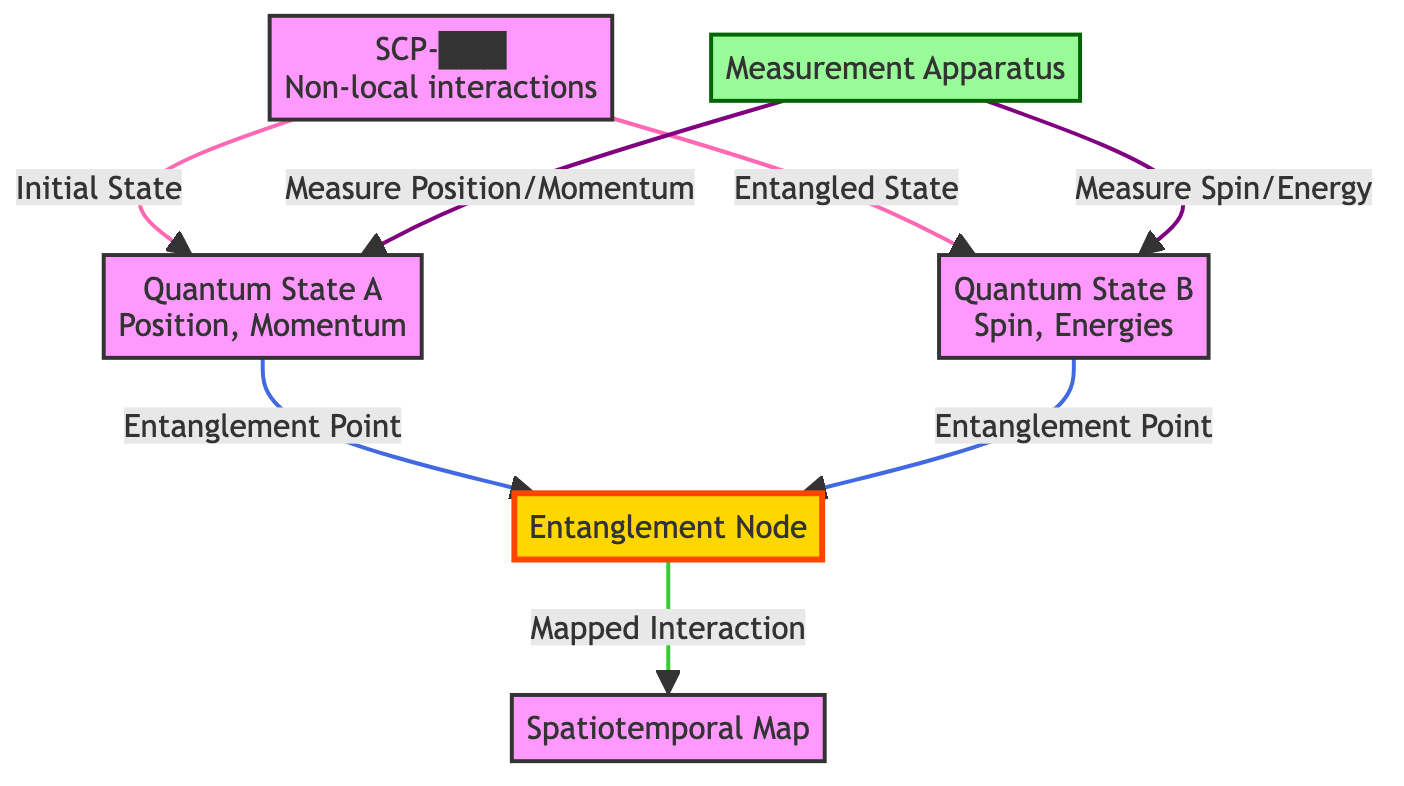What is the initial state of SCP-███? The diagram indicates that the initial state of SCP-███ is represented by node 2, labeled "Quantum State A." This node is directly connected to node 1, indicating the starting point of the system.
Answer: Quantum State A How many nodes represent the quantum states? There are two nodes that represent the quantum states: node 2 ("Quantum State A") and node 3 ("Quantum State B"). Thus, by simply counting these specific nodes, we arrive at the figure.
Answer: 2 What does the entanglement node connect to? The entanglement node (node 5) connects to both quantum state nodes (node 2 and node 3) and is also linked to the spatiotemporal map (node 4). Tracing the links will confirm these connections.
Answer: Quantum State A, Quantum State B, Spatiotemporal Map What type of mapping is indicated in the diagram? The diagram indicates a "Mapped Interaction," which is shown as a connection from the entanglement node (node 5) to the spatiotemporal map (node 4). This implies the nature of the mapping occurs here.
Answer: Mapped Interaction Which node measures position and momentum? According to the diagram, the measurement apparatus (node 6) is explicitly linked to "Measure Position/Momentum," which directly refers to quantum state A (node 2). Thus, it measures these properties.
Answer: Quantum State A What is the color used for the entanglement node? In the diagram, the entanglement node (node 5) is defined with a specific color style corresponding to the class “entanglementStyle,” which is identified in the code as yellow fill and orange stroke.
Answer: Yellow Which quantum state relates to spin and energy? The quantum state that relates to spin and energy is represented by node 3, labeled "Quantum State B." It is specifically noted as such in the diagram.
Answer: Quantum State B What two types of measurements are indicated? The diagram displays two types of measurements: "Measure Position/Momentum" and "Measure Spin/Energy," both connected to their respective quantum state nodes. Identifying these connections leads to the conclusion.
Answer: Position/Momentum, Spin/Energy How are the initial state and the entangled state related? The diagram illustrates a direct link from the initial state (node 1) to both quantum states (nodes 2 and 3), demonstrating that the initial state leads to the entangled state through these quantum states.
Answer: Through Quantum States A and B 